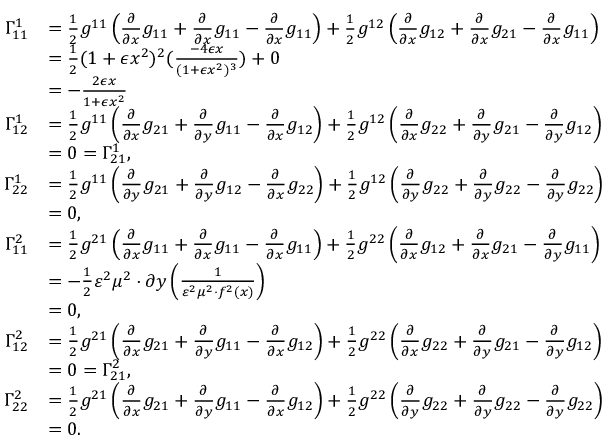<formula> <loc_0><loc_0><loc_500><loc_500>\begin{array} { r l } { \Gamma _ { 1 1 } ^ { 1 } } & { = \frac { 1 } { 2 } g ^ { 1 1 } \left ( \frac { \partial } { \partial { x } } g _ { 1 1 } + \frac { \partial } { \partial { x } } g _ { 1 1 } - \frac { \partial } { \partial { x } } g _ { 1 1 } \right ) + \frac { 1 } { 2 } g ^ { 1 2 } \left ( \frac { \partial } { \partial { x } } g _ { 1 2 } + \frac { \partial } { \partial { x } } g _ { 2 1 } - \frac { \partial } { \partial { x } } g _ { 1 1 } \right ) } \\ & { = \frac { 1 } { 2 } ( 1 + \epsilon x ^ { 2 } ) ^ { 2 } ( \frac { - 4 \epsilon x } { ( 1 + \epsilon x ^ { 2 } ) ^ { 3 } } ) + 0 } \\ & { = - \frac { 2 \epsilon x } { 1 + \epsilon x ^ { 2 } } } \\ { \Gamma _ { 1 2 } ^ { 1 } } & { = \frac { 1 } { 2 } g ^ { 1 1 } \left ( \frac { \partial } { \partial { x } } g _ { 2 1 } + \frac { \partial } { \partial { y } } g _ { 1 1 } - \frac { \partial } { \partial { x } } g _ { 1 2 } \right ) + \frac { 1 } { 2 } g ^ { 1 2 } \left ( \frac { \partial } { \partial { x } } g _ { 2 2 } + \frac { \partial } { \partial { y } } g _ { 2 1 } - \frac { \partial } { \partial { y } } g _ { 1 2 } \right ) } \\ & { = 0 = \Gamma _ { 2 1 } ^ { 1 } , } \\ { \Gamma _ { 2 2 } ^ { 1 } } & { = \frac { 1 } { 2 } g ^ { 1 1 } \left ( \frac { \partial } { \partial { y } } g _ { 2 1 } + \frac { \partial } { \partial { y } } g _ { 1 2 } - \frac { \partial } { \partial { x } } g _ { 2 2 } \right ) + \frac { 1 } { 2 } g ^ { 1 2 } \left ( \frac { \partial } { \partial { y } } g _ { 2 2 } + \frac { \partial } { \partial { y } } g _ { 2 2 } - \frac { \partial } { \partial { y } } g _ { 2 2 } \right ) } \\ & { = 0 , } \\ { \Gamma _ { 1 1 } ^ { 2 } } & { = \frac { 1 } { 2 } g ^ { 2 1 } \left ( \frac { \partial } { \partial { x } } g _ { 1 1 } + \frac { \partial } { \partial { x } } g _ { 1 1 } - \frac { \partial } { \partial { x } } g _ { 1 1 } \right ) + \frac { 1 } { 2 } g ^ { 2 2 } \left ( \frac { \partial } { \partial { x } } g _ { 1 2 } + \frac { \partial } { \partial { x } } g _ { 2 1 } - \frac { \partial } { \partial { y } } g _ { 1 1 } \right ) } \\ & { = - \frac { 1 } { 2 } \varepsilon ^ { 2 } \mu ^ { 2 } \cdot \partial { y } \left ( \frac { 1 } { \varepsilon ^ { 2 } \mu ^ { 2 } \cdot f ^ { 2 } ( x ) } \right ) } \\ & { = 0 , } \\ { \Gamma _ { 1 2 } ^ { 2 } } & { = \frac { 1 } { 2 } g ^ { 2 1 } \left ( \frac { \partial } { \partial { x } } g _ { 2 1 } + \frac { \partial } { \partial { y } } g _ { 1 1 } - \frac { \partial } { \partial { x } } g _ { 1 2 } \right ) + \frac { 1 } { 2 } g ^ { 2 2 } \left ( \frac { \partial } { \partial { x } } g _ { 2 2 } + \frac { \partial } { \partial { y } } g _ { 2 1 } - \frac { \partial } { \partial { y } } g _ { 1 2 } \right ) } \\ & { = 0 = \Gamma _ { 2 1 } ^ { 2 } , } \\ { \Gamma _ { 2 2 } ^ { 2 } } & { = \frac { 1 } { 2 } g ^ { 2 1 } \left ( \frac { \partial } { \partial { x } } g _ { 2 1 } + \frac { \partial } { \partial { y } } g _ { 1 1 } - \frac { \partial } { \partial { x } } g _ { 1 2 } \right ) + \frac { 1 } { 2 } g ^ { 2 2 } \left ( \frac { \partial } { \partial { y } } g _ { 2 2 } + \frac { \partial } { \partial { y } } g _ { 2 2 } - \frac { \partial } { \partial { y } } g _ { 2 2 } \right ) } \\ & { = 0 . } \end{array}</formula> 